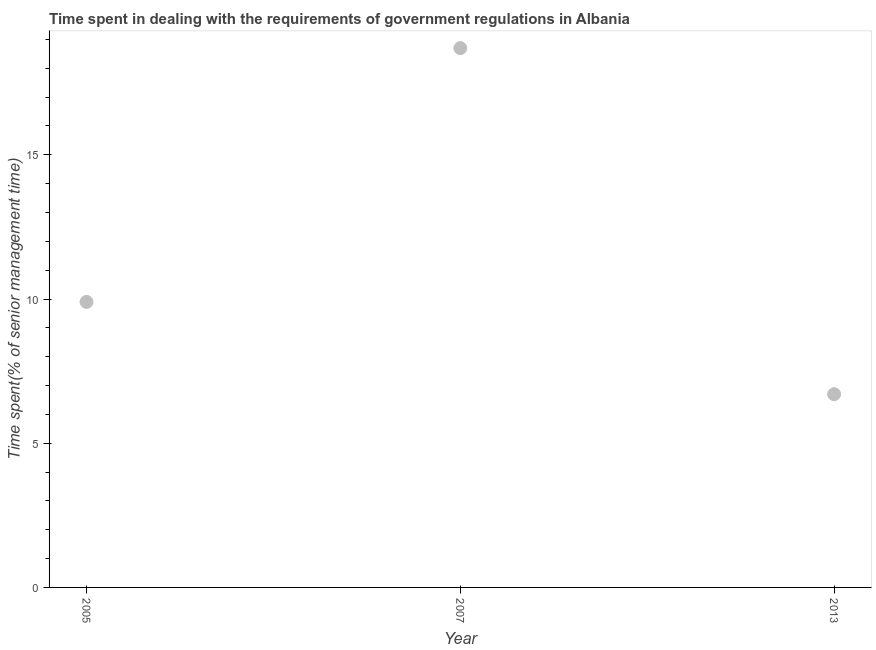What is the time spent in dealing with government regulations in 2005?
Make the answer very short. 9.9. Across all years, what is the maximum time spent in dealing with government regulations?
Your answer should be very brief. 18.7. Across all years, what is the minimum time spent in dealing with government regulations?
Your answer should be very brief. 6.7. In which year was the time spent in dealing with government regulations minimum?
Your response must be concise. 2013. What is the sum of the time spent in dealing with government regulations?
Provide a short and direct response. 35.3. What is the average time spent in dealing with government regulations per year?
Your answer should be very brief. 11.77. Do a majority of the years between 2013 and 2005 (inclusive) have time spent in dealing with government regulations greater than 11 %?
Offer a very short reply. No. What is the ratio of the time spent in dealing with government regulations in 2007 to that in 2013?
Make the answer very short. 2.79. Is the difference between the time spent in dealing with government regulations in 2005 and 2013 greater than the difference between any two years?
Provide a succinct answer. No. What is the difference between the highest and the second highest time spent in dealing with government regulations?
Your answer should be very brief. 8.8. Is the sum of the time spent in dealing with government regulations in 2005 and 2013 greater than the maximum time spent in dealing with government regulations across all years?
Offer a terse response. No. In how many years, is the time spent in dealing with government regulations greater than the average time spent in dealing with government regulations taken over all years?
Give a very brief answer. 1. Does the time spent in dealing with government regulations monotonically increase over the years?
Keep it short and to the point. No. How many dotlines are there?
Give a very brief answer. 1. What is the difference between two consecutive major ticks on the Y-axis?
Provide a short and direct response. 5. Are the values on the major ticks of Y-axis written in scientific E-notation?
Give a very brief answer. No. What is the title of the graph?
Offer a terse response. Time spent in dealing with the requirements of government regulations in Albania. What is the label or title of the Y-axis?
Provide a short and direct response. Time spent(% of senior management time). What is the Time spent(% of senior management time) in 2007?
Your response must be concise. 18.7. What is the Time spent(% of senior management time) in 2013?
Provide a short and direct response. 6.7. What is the difference between the Time spent(% of senior management time) in 2005 and 2007?
Offer a terse response. -8.8. What is the difference between the Time spent(% of senior management time) in 2005 and 2013?
Make the answer very short. 3.2. What is the ratio of the Time spent(% of senior management time) in 2005 to that in 2007?
Keep it short and to the point. 0.53. What is the ratio of the Time spent(% of senior management time) in 2005 to that in 2013?
Provide a succinct answer. 1.48. What is the ratio of the Time spent(% of senior management time) in 2007 to that in 2013?
Keep it short and to the point. 2.79. 